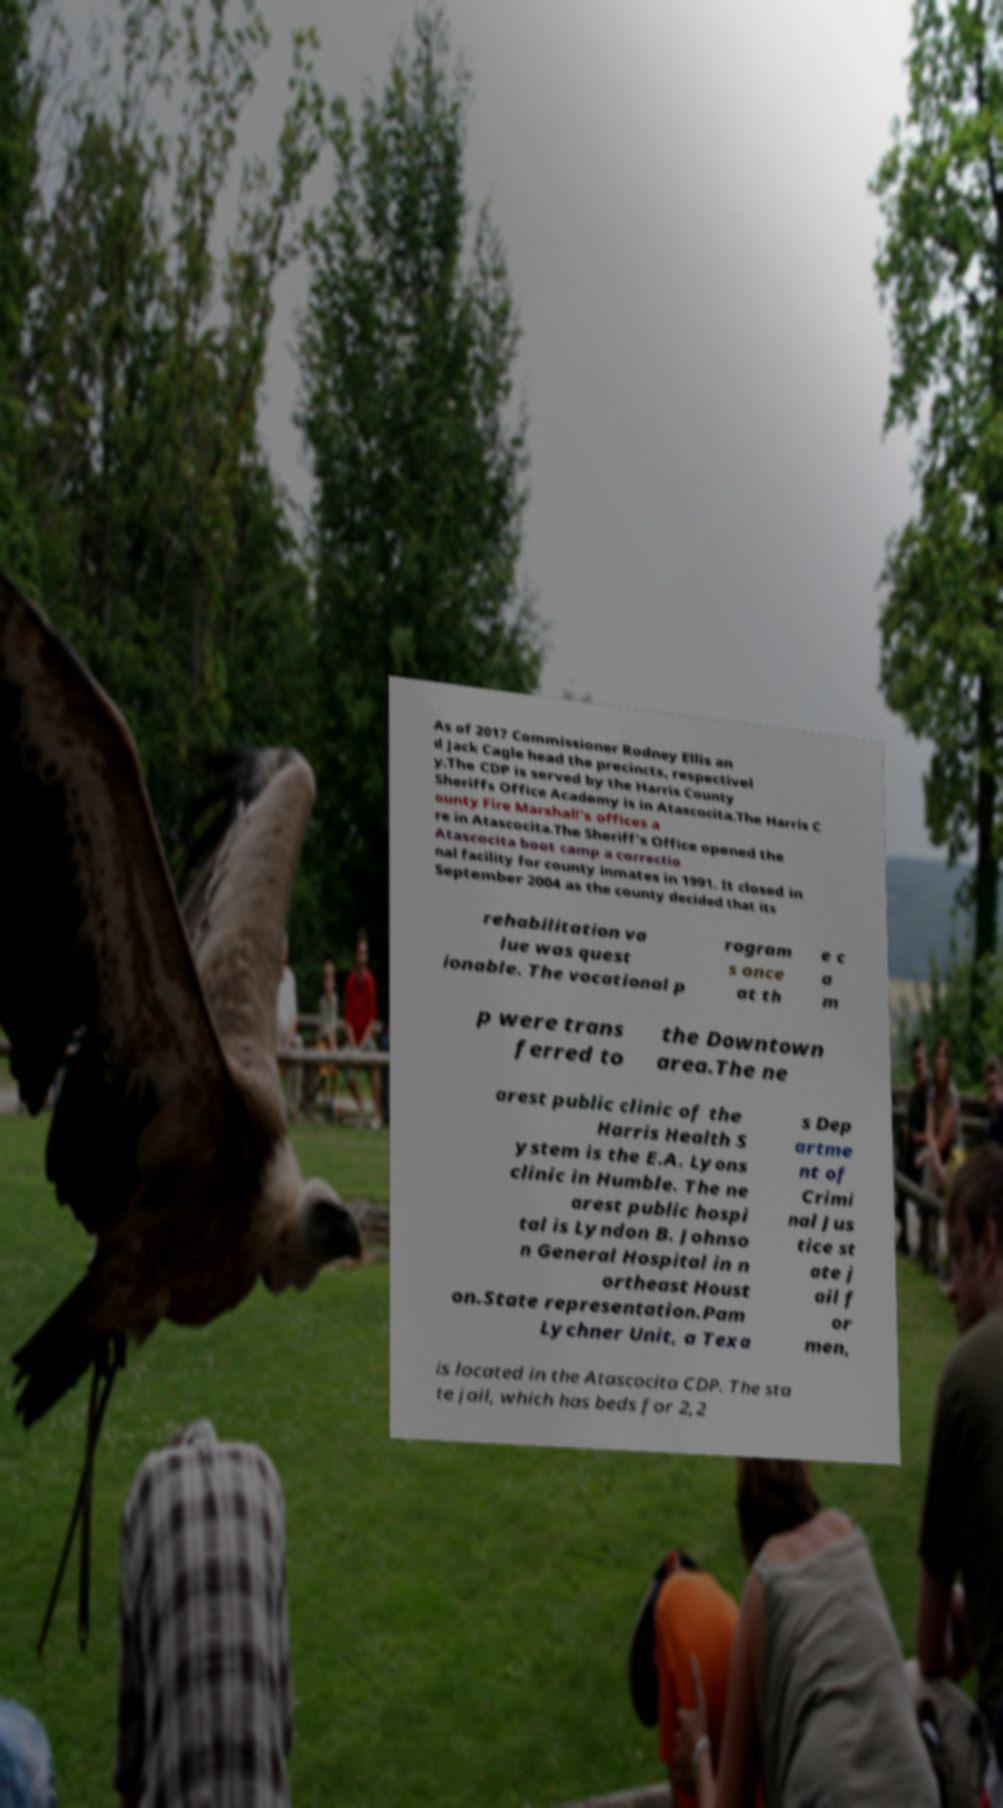I need the written content from this picture converted into text. Can you do that? As of 2017 Commissioner Rodney Ellis an d Jack Cagle head the precincts, respectivel y.The CDP is served by the Harris County Sheriffs Office Academy is in Atascocita.The Harris C ounty Fire Marshall's offices a re in Atascocita.The Sheriff's Office opened the Atascocita boot camp a correctio nal facility for county inmates in 1991. It closed in September 2004 as the county decided that its rehabilitation va lue was quest ionable. The vocational p rogram s once at th e c a m p were trans ferred to the Downtown area.The ne arest public clinic of the Harris Health S ystem is the E.A. Lyons clinic in Humble. The ne arest public hospi tal is Lyndon B. Johnso n General Hospital in n ortheast Houst on.State representation.Pam Lychner Unit, a Texa s Dep artme nt of Crimi nal Jus tice st ate j ail f or men, is located in the Atascocita CDP. The sta te jail, which has beds for 2,2 